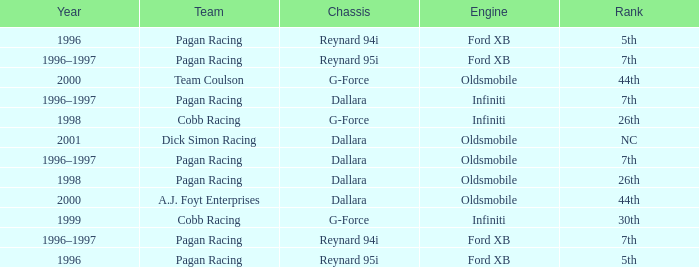Could you help me parse every detail presented in this table? {'header': ['Year', 'Team', 'Chassis', 'Engine', 'Rank'], 'rows': [['1996', 'Pagan Racing', 'Reynard 94i', 'Ford XB', '5th'], ['1996–1997', 'Pagan Racing', 'Reynard 95i', 'Ford XB', '7th'], ['2000', 'Team Coulson', 'G-Force', 'Oldsmobile', '44th'], ['1996–1997', 'Pagan Racing', 'Dallara', 'Infiniti', '7th'], ['1998', 'Cobb Racing', 'G-Force', 'Infiniti', '26th'], ['2001', 'Dick Simon Racing', 'Dallara', 'Oldsmobile', 'NC'], ['1996–1997', 'Pagan Racing', 'Dallara', 'Oldsmobile', '7th'], ['1998', 'Pagan Racing', 'Dallara', 'Oldsmobile', '26th'], ['2000', 'A.J. Foyt Enterprises', 'Dallara', 'Oldsmobile', '44th'], ['1999', 'Cobb Racing', 'G-Force', 'Infiniti', '30th'], ['1996–1997', 'Pagan Racing', 'Reynard 94i', 'Ford XB', '7th'], ['1996', 'Pagan Racing', 'Reynard 95i', 'Ford XB', '5th']]} What rank did the dallara chassis finish in 2000? 44th. 